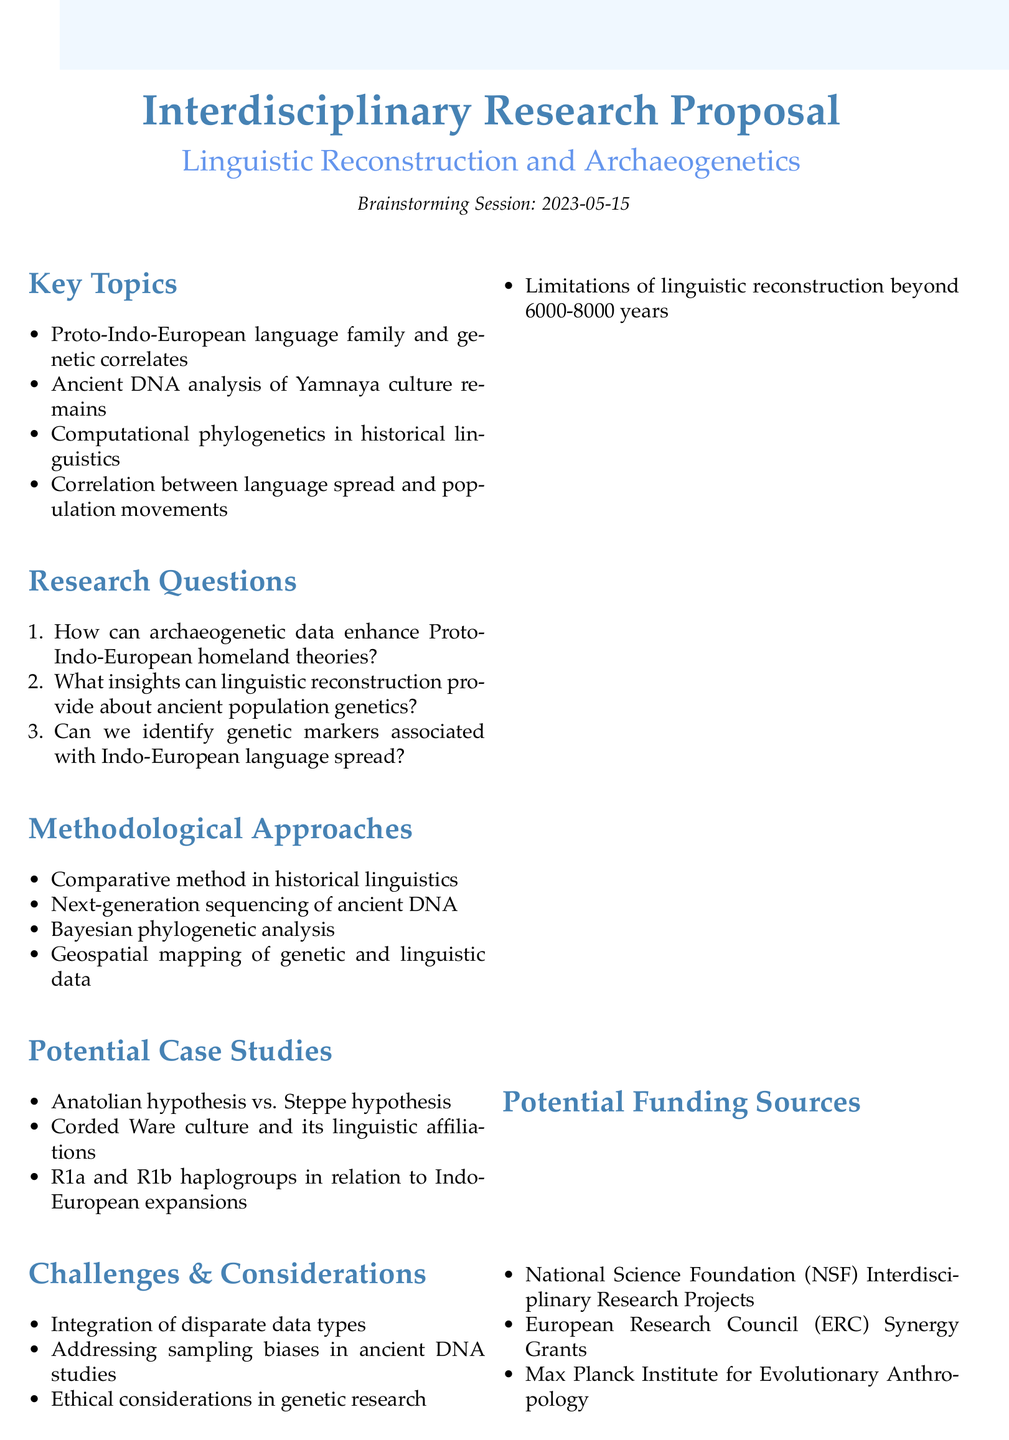what is the date of the brainstorming session? The date is explicitly stated in the session details section of the document.
Answer: 2023-05-15 who is a participant from Genetics? This question refers to the list of participants, where each person's role is identified.
Answer: Dr. Emma Patel what is one potential research question? The document outlines three potential research questions, any of which can be used as an example.
Answer: How can archaeogenetic data enhance our understanding of Proto-Indo-European homeland theories? name one methodological approach mentioned in the document. The document lists several methodological approaches under that section.
Answer: Next-generation sequencing of ancient DNA how many potential funding sources are listed? The funding sources section mentions specific organizations, allowing for a simple numerical answer.
Answer: 3 which hypothesis is compared to the Steppe hypothesis in a case study? This requires recalling specific information about the case studies from the document.
Answer: Anatolian hypothesis what is one challenge mentioned regarding the proposed research? The document outlines various challenges, allowing for a concise response.
Answer: Integration of disparate data types who is listed as the participant from Linguistics? The participant from Linguistics is specifically named in the document's participant list.
Answer: Dr. Sarah Chen 